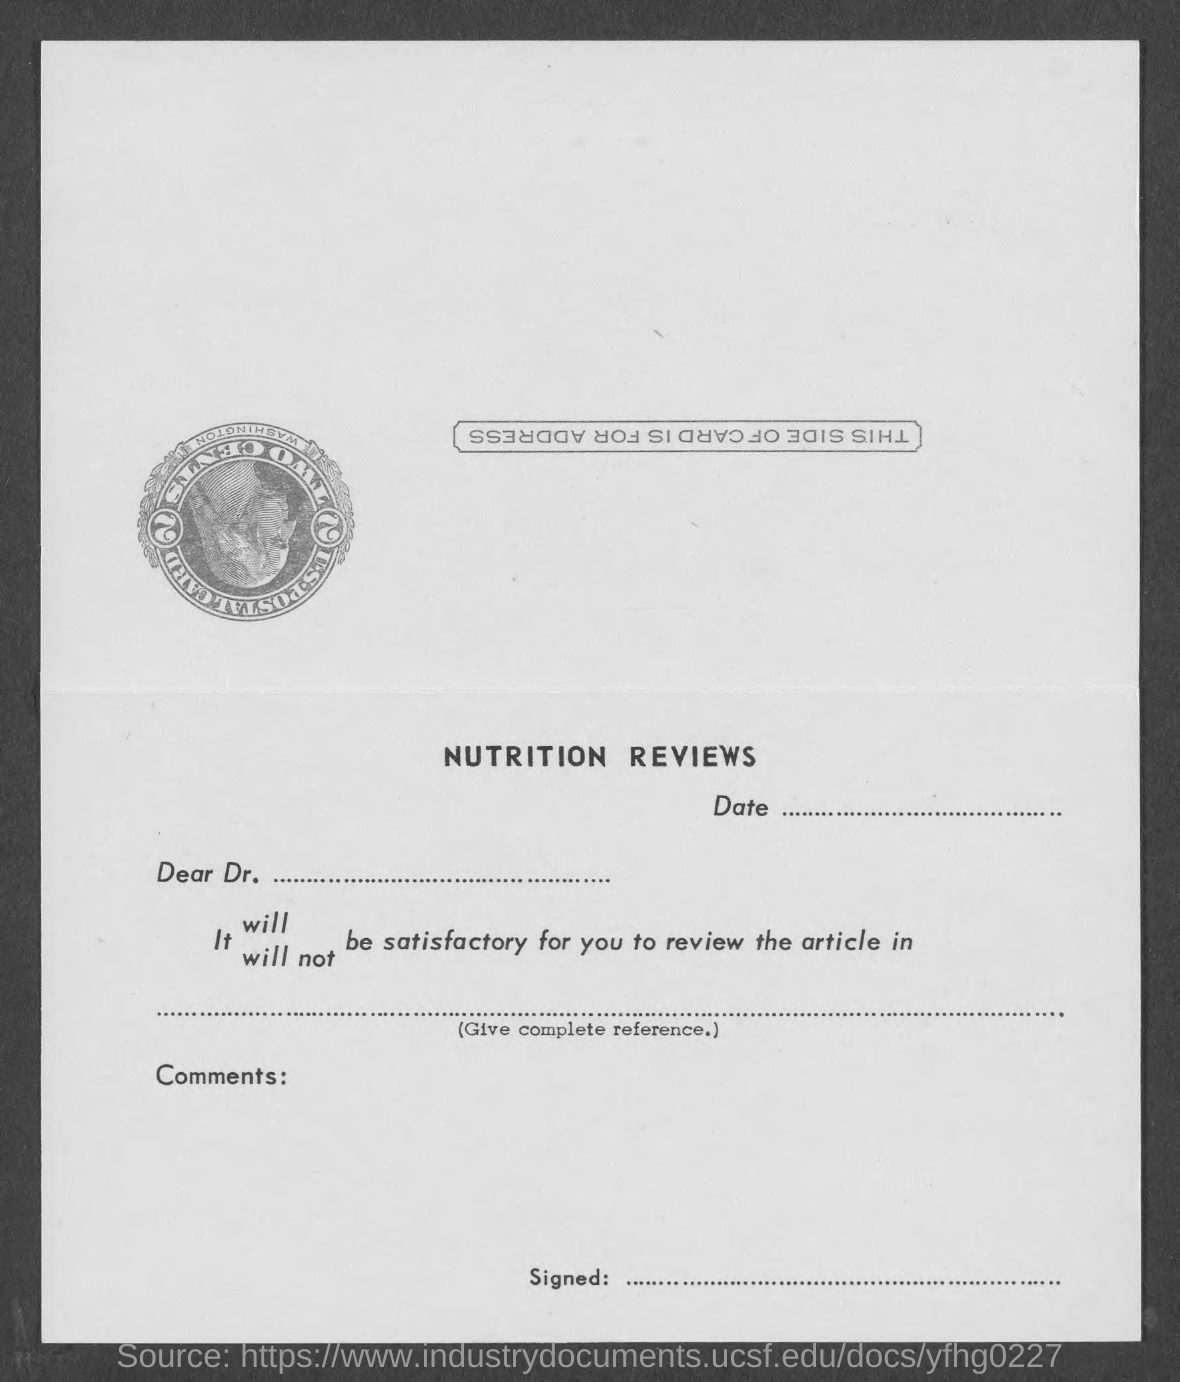Indicate a few pertinent items in this graphic. The heading is "What is the heading? NUTRITION REVIEWS... The salutation of the letter is 'Dear Dr...'. 